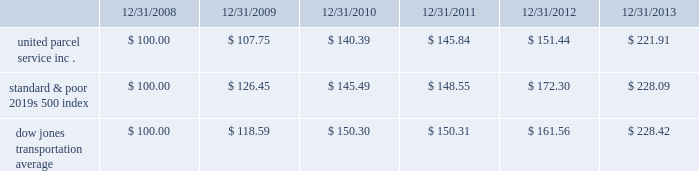Shareowner return performance graph the following performance graph and related information shall not be deemed 201csoliciting material 201d or to be 201cfiled 201d with the sec , nor shall such information be incorporated by reference into any future filing under the securities act of 1933 or securities exchange act of 1934 , each as amended , except to the extent that the company specifically incorporates such information by reference into such filing .
The following graph shows a five year comparison of cumulative total shareowners 2019 returns for our class b common stock , the standard & poor 2019s 500 index , and the dow jones transportation average .
The comparison of the total cumulative return on investment , which is the change in the quarterly stock price plus reinvested dividends for each of the quarterly periods , assumes that $ 100 was invested on december 31 , 2008 in the standard & poor 2019s 500 index , the dow jones transportation average , and our class b common stock. .

What is the difference in performance for the five years ended 12/21/2013 between united parcel service inc . and the standard & poor's 500 index? 
Computations: ((221.91 - 100) - (228.09 - 100))
Answer: -6.18. 